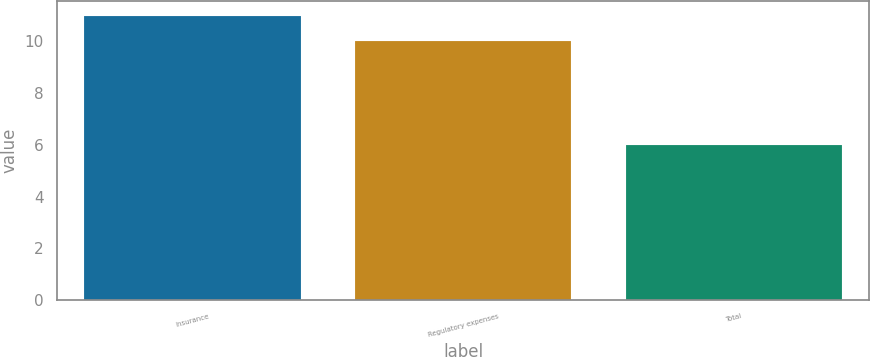Convert chart. <chart><loc_0><loc_0><loc_500><loc_500><bar_chart><fcel>Insurance<fcel>Regulatory expenses<fcel>Total<nl><fcel>11<fcel>10<fcel>6<nl></chart> 